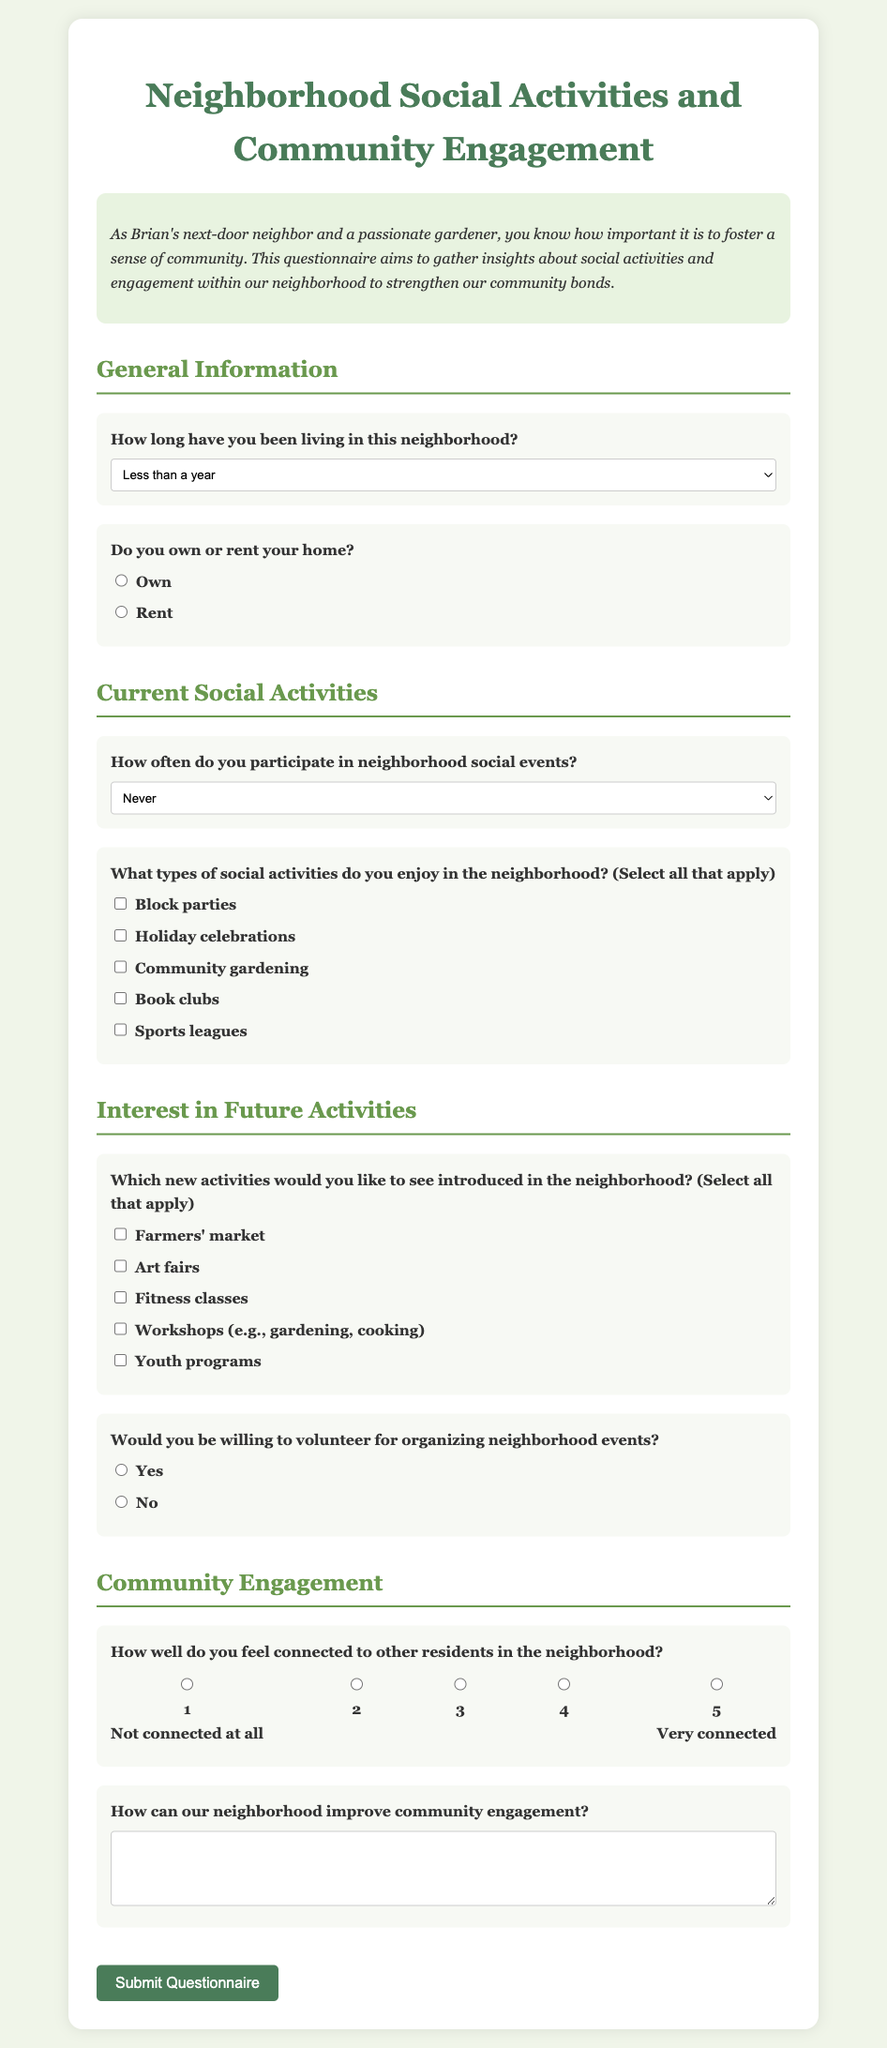How long have you lived in this neighborhood? The document provides options under "General Information" regarding the length of residence in the neighborhood.
Answer: Less than a year What question asks about home ownership? The section for "General Information" includes a question regarding whether residents own or rent their homes.
Answer: Do you own or rent your home? What type of activities can you enjoy in the neighborhood? The questionnaire lists several activities under "Current Social Activities" that residents may enjoy, asking for multiple selections.
Answer: Block parties, Holiday celebrations, Community gardening, Book clubs, Sports leagues Which new activity is suggested for the neighborhood? The document lists various proposed new activities under "Interest in Future Activities" that residents would like to see introduced.
Answer: Farmers' market How connected do residents feel to others in the neighborhood? The questionnaire includes a scale question regarding residents' feelings of connection, providing a numerical rating from 1 to 5.
Answer: 1 to 5 What is the purpose of the questionnaire? The introduction outlines the goal of the questionnaire to gather insights about social activities and community engagement.
Answer: Strengthen community bonds Would you be willing to volunteer? The document explicitly asks residents if they would volunteer to help organize neighborhood events under "Interest in Future Activities."
Answer: Yes or No What feedback does the questionnaire solicit about community engagement? The final question in the document seeks residents' opinions on how to improve community engagement.
Answer: Suggestions for improvement 